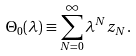<formula> <loc_0><loc_0><loc_500><loc_500>\Theta _ { 0 } ( \lambda ) \equiv \sum _ { N = 0 } ^ { \infty } \lambda ^ { N } z _ { N } .</formula> 